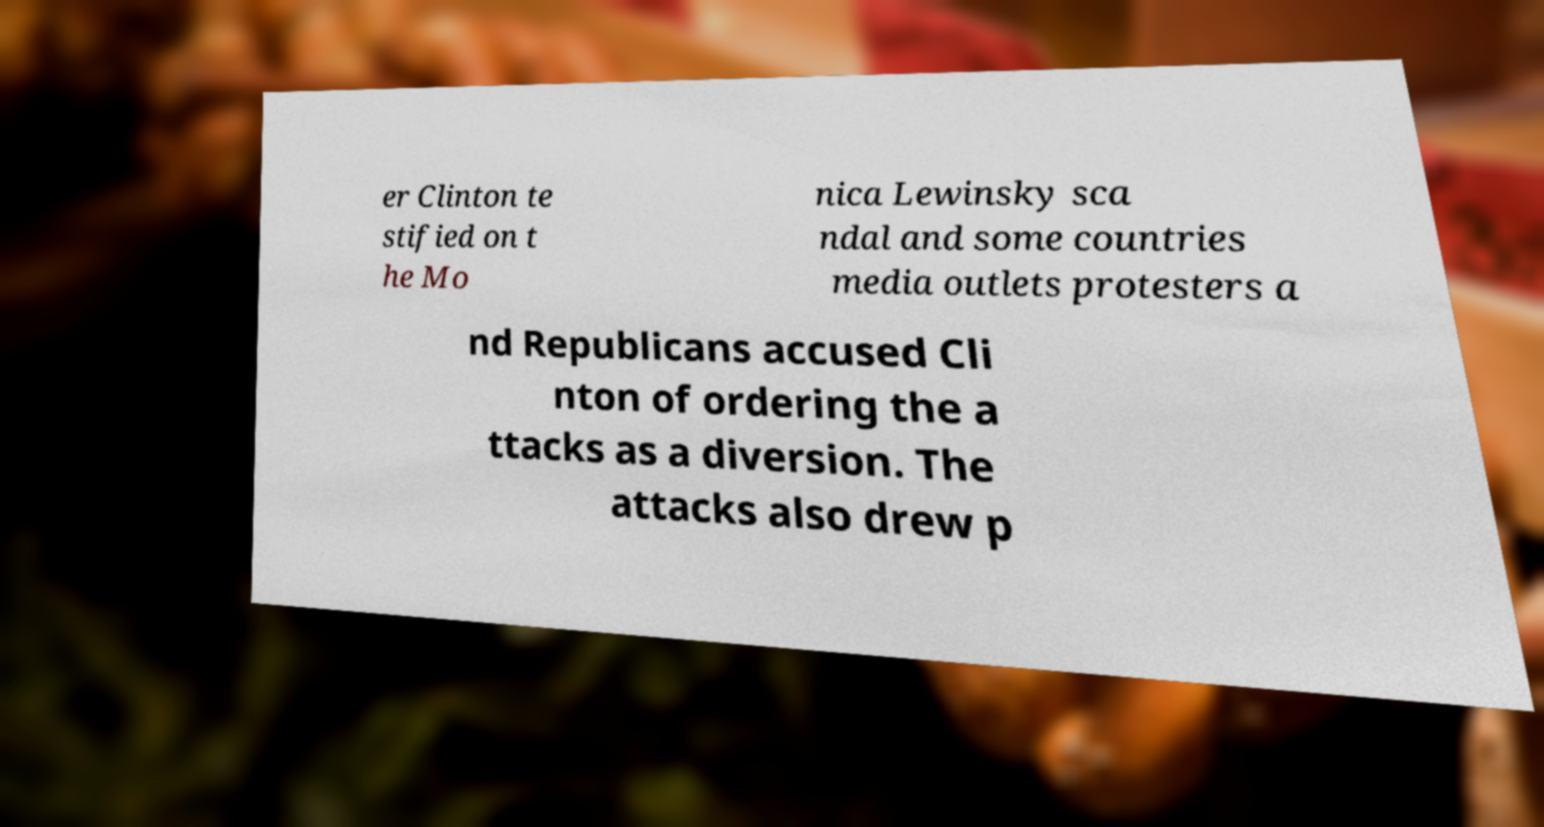For documentation purposes, I need the text within this image transcribed. Could you provide that? er Clinton te stified on t he Mo nica Lewinsky sca ndal and some countries media outlets protesters a nd Republicans accused Cli nton of ordering the a ttacks as a diversion. The attacks also drew p 